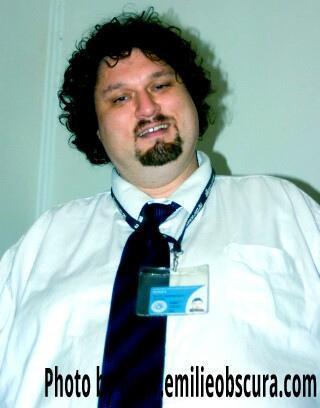How many people are in the picture?
Give a very brief answer. 1. 